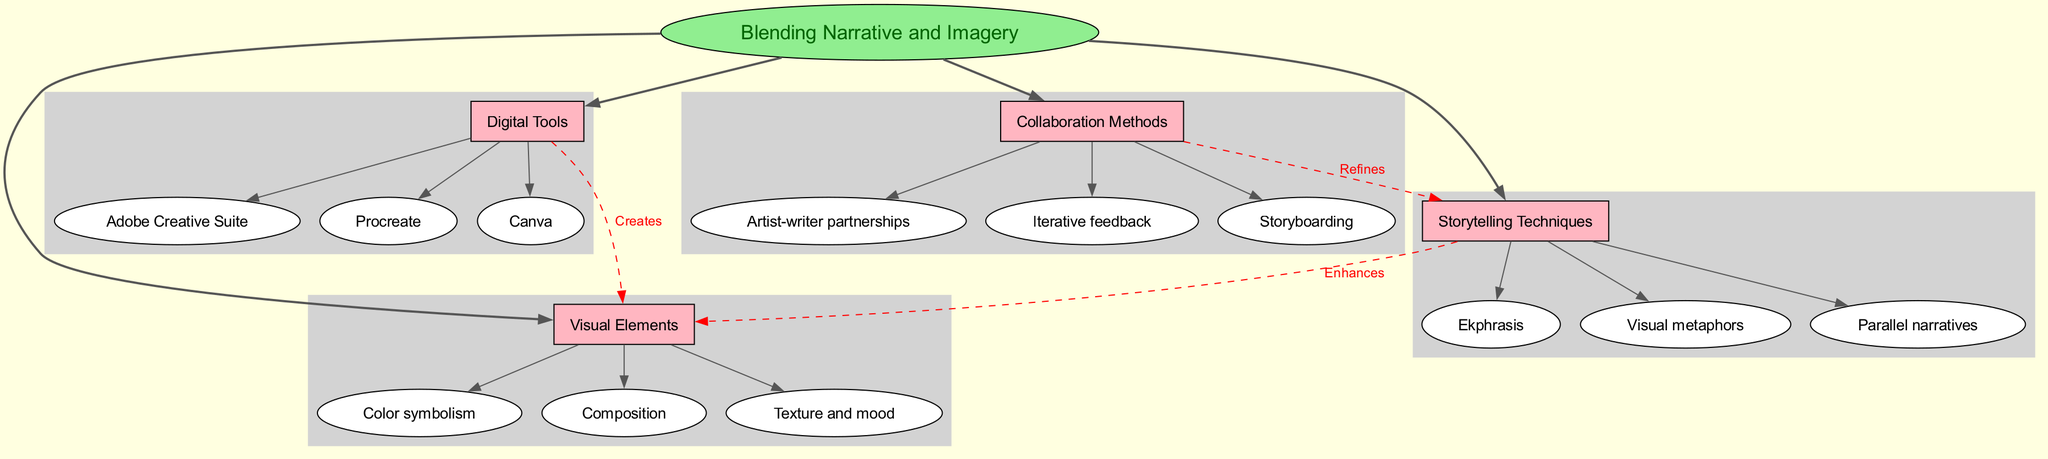What is the central concept of the diagram? The central concept is located at the center of the diagram, which represents the main idea that connects all other elements. The diagram explicitly labels the central concept as "Blending Narrative and Imagery."
Answer: Blending Narrative and Imagery How many main branches are displayed in the diagram? I can count the main branches that extend from the central concept. There are four distinct branches named "Storytelling Techniques," "Visual Elements," "Digital Tools," and "Collaboration Methods."
Answer: 4 Which storytelling technique is listed under the main branch of Storytelling Techniques? Looking at the sub-branches connected to "Storytelling Techniques," I can see the specific techniques provided. One of them is "Ekphrasis."
Answer: Ekphrasis What relationship connects Digital Tools and Visual Elements? The connection between "Digital Tools" and "Visual Elements" is indicated in the diagram by an edge. The label on this edge reads "Creates," meaning that Digital Tools generate Visual Elements.
Answer: Creates What method refines Storytelling Techniques according to the diagram? In examining the connections from the "Collaboration Methods" branch, I find a direct link to "Storytelling Techniques." The label on this connection signifies that "Collaboration Methods" refine them.
Answer: Refines Which visual element is associated with color in the diagram? I can see the sub-branch "Color symbolism" listed under the main branch "Visual Elements," indicating its specific focus area.
Answer: Color symbolism How many sub-branches are listed under the Visual Elements branch? To determine the number of sub-branches under "Visual Elements," I can count them directly from the diagram. There are three sub-branches: "Color symbolism," "Composition," and "Texture and mood."
Answer: 3 What connection describes the flow from Storytelling Techniques to Visual Elements? The edge connecting "Storytelling Techniques" and "Visual Elements" is labeled in the diagram, indicating a specific relationship. The label states "Enhances," suggesting that storytelling techniques improve or augment visual elements.
Answer: Enhances Which digital tool is mentioned in the Digital Tools branch? By inspecting the sub-branches under "Digital Tools," I can identify distinct tools. One of the tools listed is "Adobe Creative Suite."
Answer: Adobe Creative Suite 